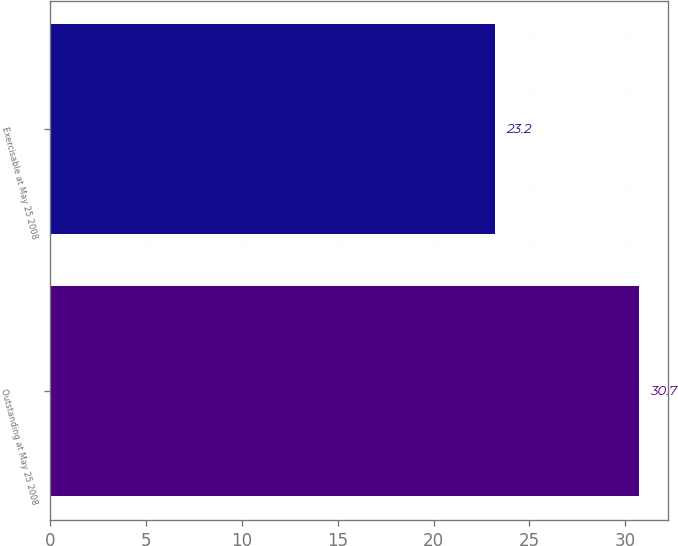<chart> <loc_0><loc_0><loc_500><loc_500><bar_chart><fcel>Outstanding at May 25 2008<fcel>Exercisable at May 25 2008<nl><fcel>30.7<fcel>23.2<nl></chart> 